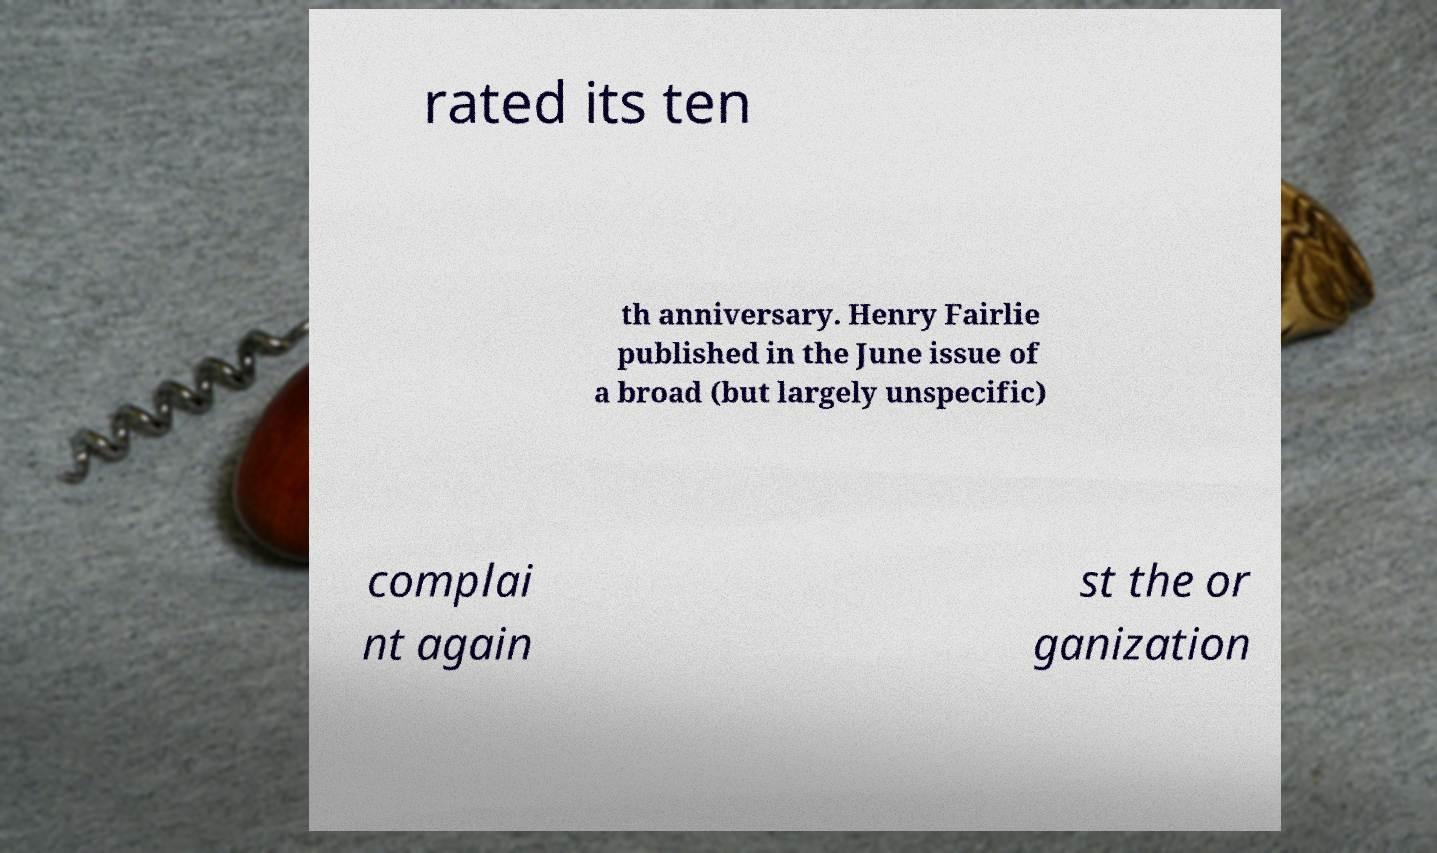Could you extract and type out the text from this image? rated its ten th anniversary. Henry Fairlie published in the June issue of a broad (but largely unspecific) complai nt again st the or ganization 